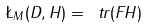Convert formula to latex. <formula><loc_0><loc_0><loc_500><loc_500>\L _ { M } ( D , H ) = \ t r ( F H )</formula> 